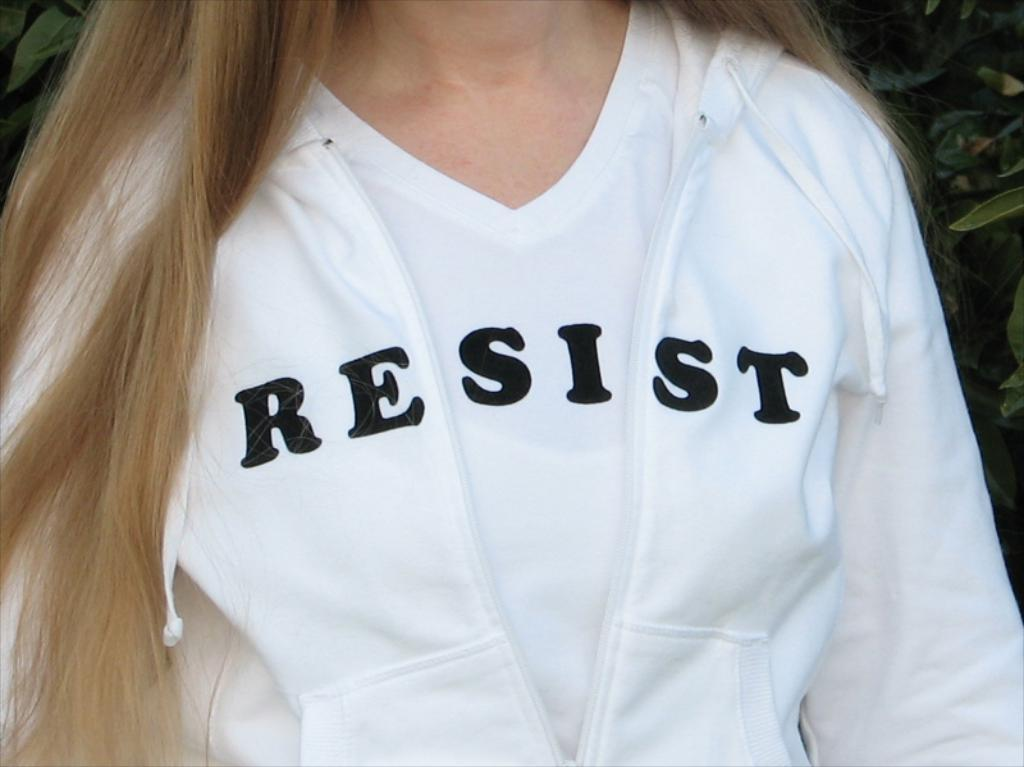Who or what is the main subject of the image? There is a person in the image. What is the person wearing? The person is wearing a white jacket. What can be seen in the background of the image? There are plants in the background of the image. What type of ghost can be seen interacting with the person in the image? There is no ghost present in the image; only the person and plants are visible. What kind of competition is the person participating in within the image? There is no competition present in the image; it simply features a person wearing a white jacket with plants in the background. 